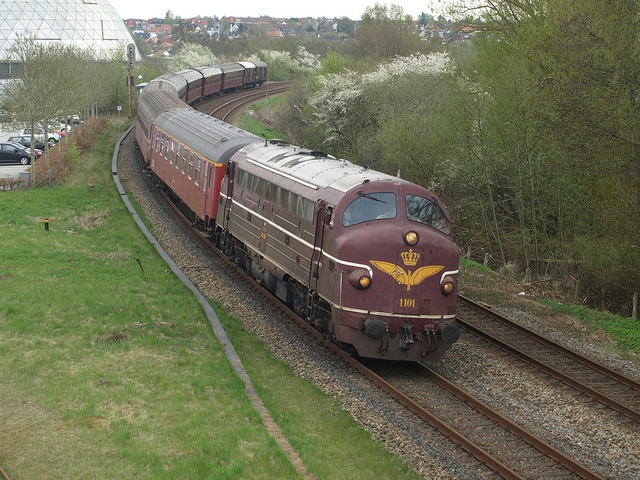Describe the objects in this image and their specific colors. I can see train in white, gray, black, darkgray, and maroon tones, car in white, black, gray, darkgray, and lightgray tones, car in white, darkgray, lightgray, and gray tones, car in white, gray, darkgray, and lightgray tones, and car in white, gray, darkgray, and black tones in this image. 